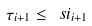<formula> <loc_0><loc_0><loc_500><loc_500>\tau _ { i + 1 } \leq \ s i _ { i + 1 }</formula> 